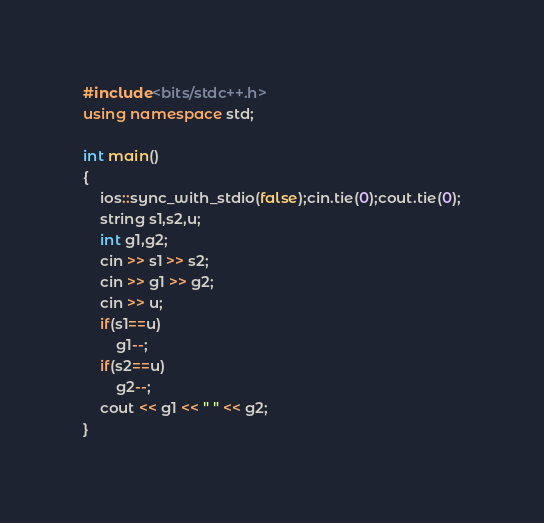<code> <loc_0><loc_0><loc_500><loc_500><_C++_>#include<bits/stdc++.h>
using namespace std;

int main()
{
    ios::sync_with_stdio(false);cin.tie(0);cout.tie(0);
    string s1,s2,u;
    int g1,g2;
    cin >> s1 >> s2;
    cin >> g1 >> g2;
    cin >> u;
    if(s1==u)
        g1--;
    if(s2==u)
        g2--;
    cout << g1 << " " << g2;
}
</code> 